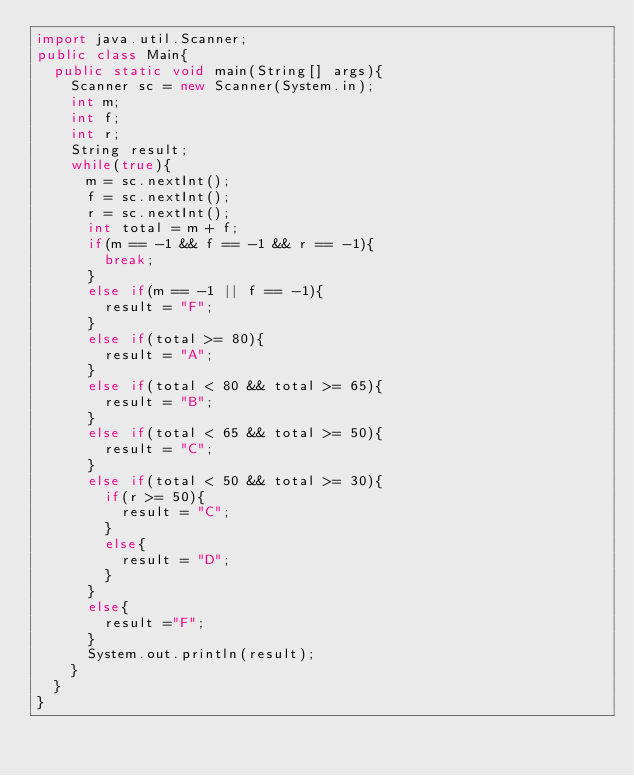<code> <loc_0><loc_0><loc_500><loc_500><_Java_>import java.util.Scanner;
public class Main{
  public static void main(String[] args){
    Scanner sc = new Scanner(System.in);
    int m;
    int f;
    int r;
    String result;
    while(true){
      m = sc.nextInt();
      f = sc.nextInt();
      r = sc.nextInt();
      int total = m + f;
      if(m == -1 && f == -1 && r == -1){
        break;
      }
      else if(m == -1 || f == -1){
        result = "F";
      }
      else if(total >= 80){
        result = "A";
      }
      else if(total < 80 && total >= 65){
        result = "B";
      }
      else if(total < 65 && total >= 50){
        result = "C";
      }
      else if(total < 50 && total >= 30){
        if(r >= 50){
          result = "C";
        }
        else{
          result = "D";
        }
      }
      else{
        result ="F";
      }
      System.out.println(result);
    }
  }
}

</code> 